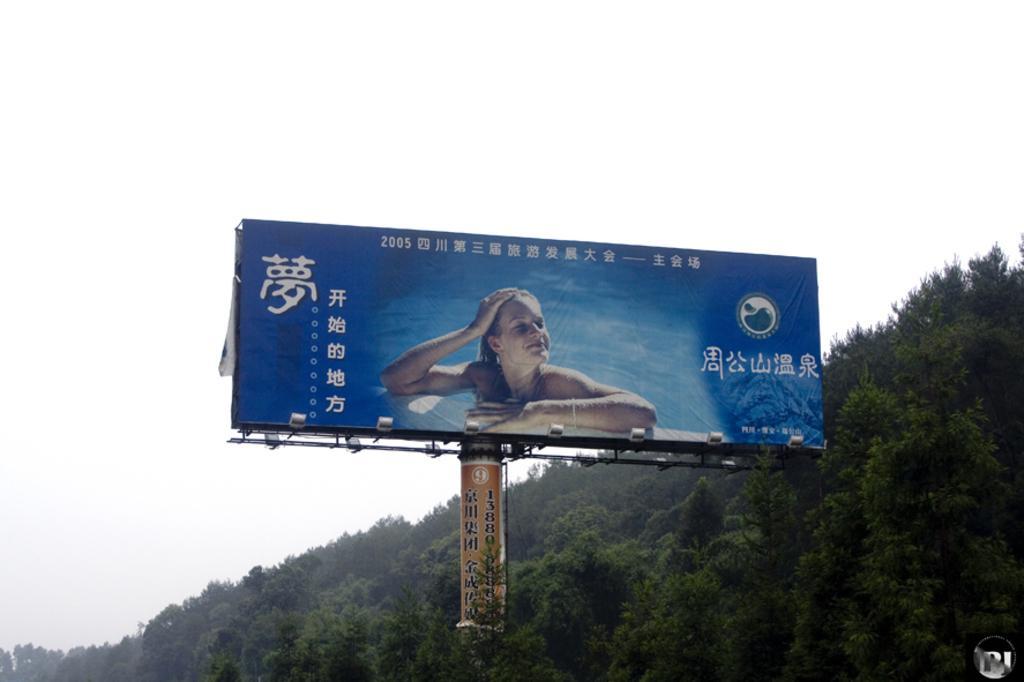Describe this image in one or two sentences. In this image, we can see a hoarding and in the background, there are trees. 